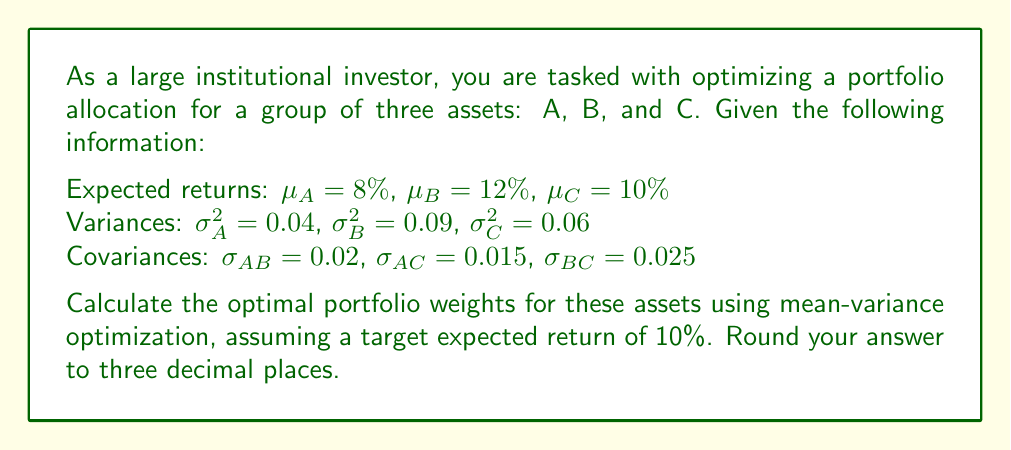Provide a solution to this math problem. To solve this problem, we'll use the mean-variance optimization approach. The steps are as follows:

1) First, we need to set up the optimization problem. We want to minimize the portfolio variance subject to the constraints of achieving the target return and the weights summing to 1.

2) The portfolio variance is given by:
   $$\sigma_p^2 = w_A^2\sigma_A^2 + w_B^2\sigma_B^2 + w_C^2\sigma_C^2 + 2w_Aw_B\sigma_{AB} + 2w_Aw_C\sigma_{AC} + 2w_Bw_C\sigma_{BC}$$

3) The expected portfolio return is:
   $$\mu_p = w_A\mu_A + w_B\mu_B + w_C\mu_C$$

4) We can set up the Lagrangian function:
   $$L = \sigma_p^2 + \lambda_1(\mu_p - 0.10) + \lambda_2(w_A + w_B + w_C - 1)$$

5) Taking partial derivatives with respect to $w_A$, $w_B$, $w_C$, $\lambda_1$, and $\lambda_2$, and setting them to zero:

   $$\frac{\partial L}{\partial w_A} = 2w_A\sigma_A^2 + 2w_B\sigma_{AB} + 2w_C\sigma_{AC} + \lambda_1\mu_A + \lambda_2 = 0$$
   $$\frac{\partial L}{\partial w_B} = 2w_B\sigma_B^2 + 2w_A\sigma_{AB} + 2w_C\sigma_{BC} + \lambda_1\mu_B + \lambda_2 = 0$$
   $$\frac{\partial L}{\partial w_C} = 2w_C\sigma_C^2 + 2w_A\sigma_{AC} + 2w_B\sigma_{BC} + \lambda_1\mu_C + \lambda_2 = 0$$
   $$\frac{\partial L}{\partial \lambda_1} = w_A\mu_A + w_B\mu_B + w_C\mu_C - 0.10 = 0$$
   $$\frac{\partial L}{\partial \lambda_2} = w_A + w_B + w_C - 1 = 0$$

6) Solving this system of equations (which can be done using matrix algebra or a computer algebra system), we get the optimal weights.

7) After solving and rounding to three decimal places, we obtain the optimal weights.
Answer: The optimal portfolio weights are:
$w_A = 0.404$
$w_B = 0.263$
$w_C = 0.333$ 